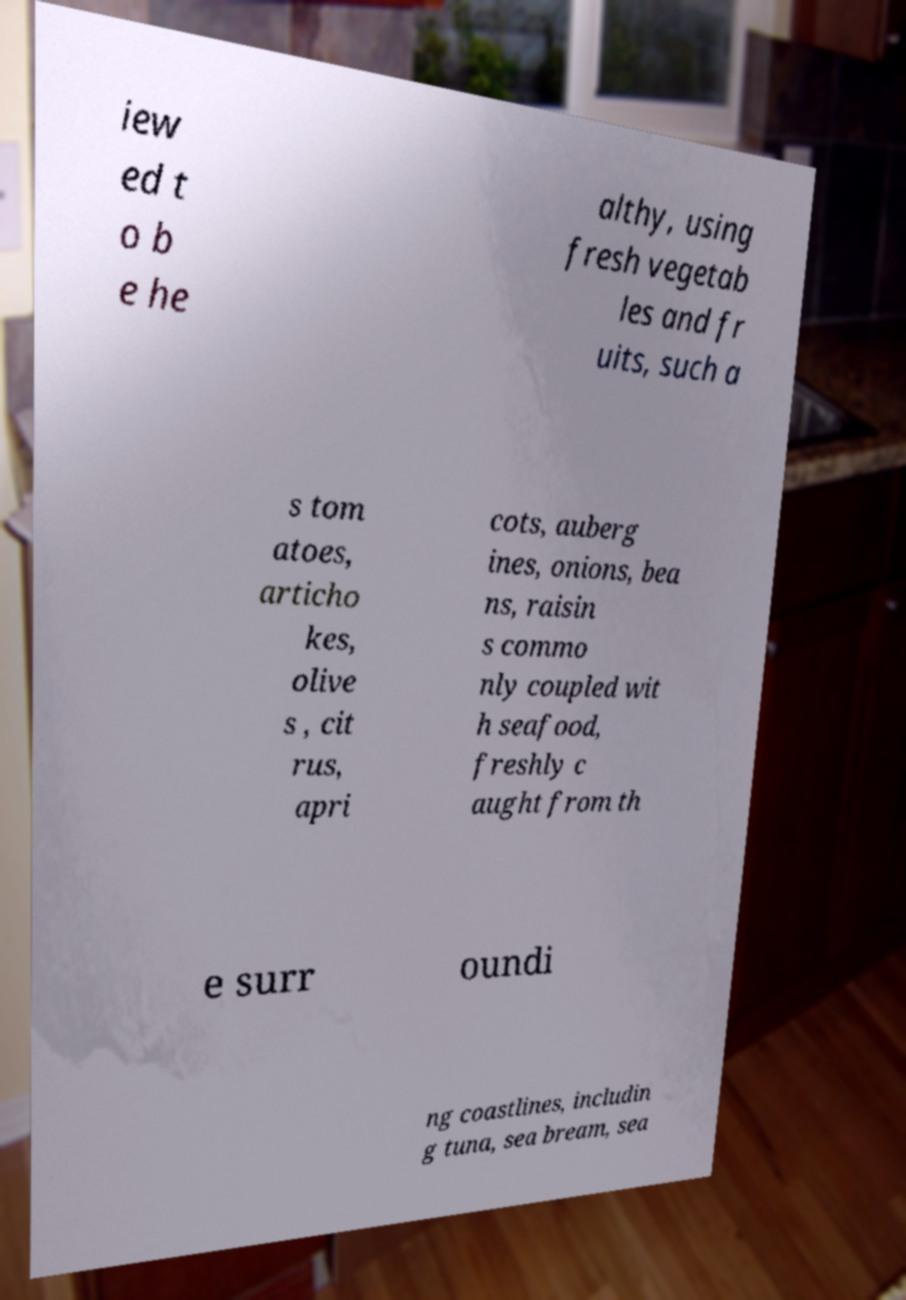There's text embedded in this image that I need extracted. Can you transcribe it verbatim? iew ed t o b e he althy, using fresh vegetab les and fr uits, such a s tom atoes, articho kes, olive s , cit rus, apri cots, auberg ines, onions, bea ns, raisin s commo nly coupled wit h seafood, freshly c aught from th e surr oundi ng coastlines, includin g tuna, sea bream, sea 